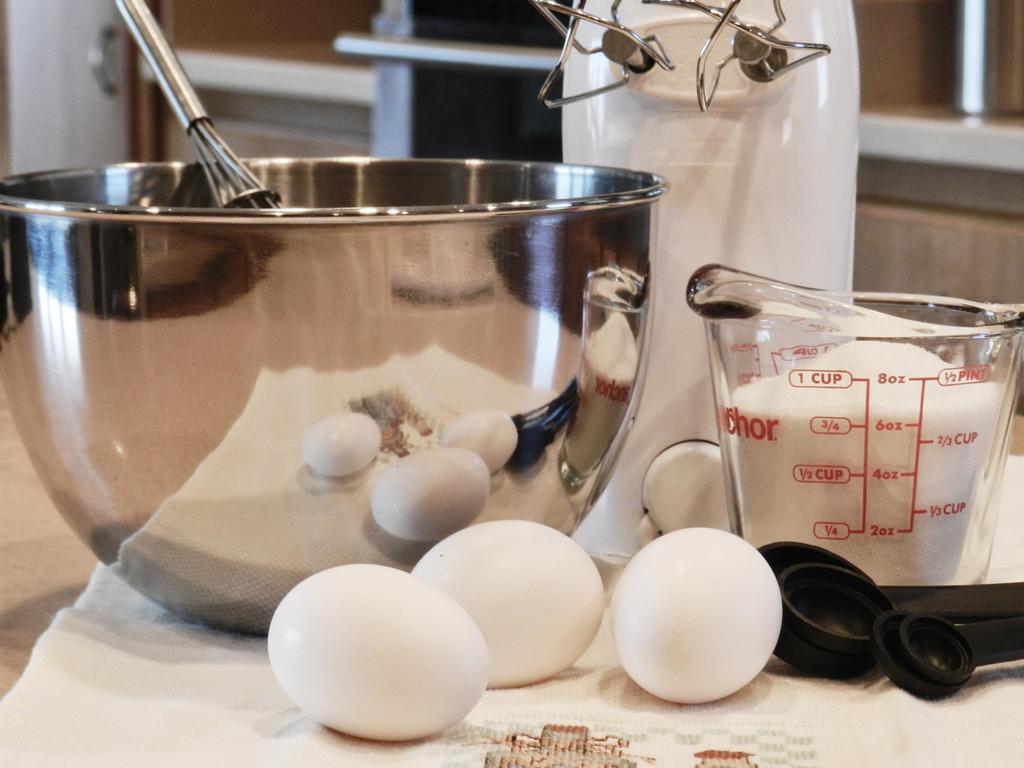How much milk is measured?
Provide a short and direct response. 3/4 cup. What is the greatest cup measurement on the measurer?
Provide a short and direct response. 1 cup. 